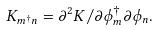<formula> <loc_0><loc_0><loc_500><loc_500>K _ { m ^ { \dag } n } = \partial ^ { 2 } K / \partial \phi ^ { \dag } _ { m } \partial \phi _ { n } .</formula> 